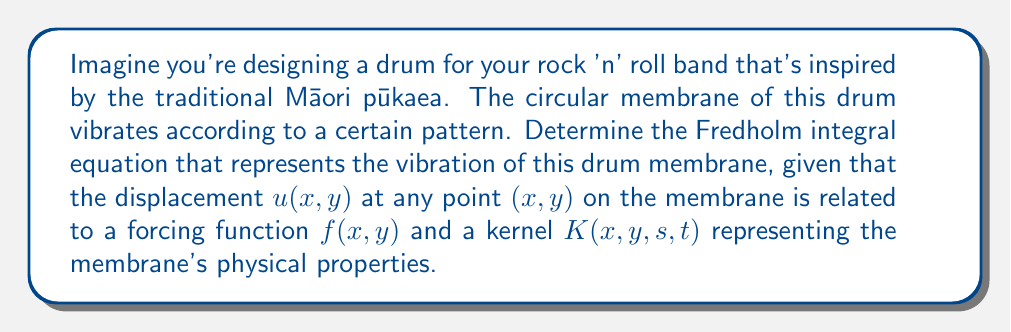Give your solution to this math problem. Let's approach this step-by-step:

1) The vibration of a drum membrane can be modeled using a Fredholm integral equation of the second kind.

2) The general form of a 2D Fredholm integral equation of the second kind is:

   $$u(x,y) = f(x,y) + \lambda \int\int_D K(x,y,s,t)u(s,t)dsdt$$

   where $D$ is the domain of the membrane (in this case, a circle).

3) In this equation:
   - $u(x,y)$ is the displacement of the membrane at point $(x,y)$
   - $f(x,y)$ is the forcing function (external force applied to the membrane)
   - $K(x,y,s,t)$ is the kernel function, which represents the membrane's response to a point force
   - $\lambda$ is a parameter that depends on the membrane's physical properties

4) For a circular membrane of radius $a$, the domain $D$ would be:

   $$D = \{(s,t) : s^2 + t^2 \leq a^2\}$$

5) The kernel function $K(x,y,s,t)$ for a drum membrane typically involves Bessel functions, but its exact form depends on the specific boundary conditions and physical properties of the membrane.

6) Putting this all together, the Fredholm integral equation for the vibration of the drum membrane is:

   $$u(x,y) = f(x,y) + \lambda \int\int_{s^2+t^2\leq a^2} K(x,y,s,t)u(s,t)dsdt$$

This equation relates the displacement $u(x,y)$ at any point on the membrane to the forcing function and the membrane's response to vibrations at all other points.
Answer: $$u(x,y) = f(x,y) + \lambda \int\int_{s^2+t^2\leq a^2} K(x,y,s,t)u(s,t)dsdt$$ 